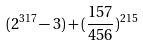<formula> <loc_0><loc_0><loc_500><loc_500>( 2 ^ { 3 1 7 } - 3 ) + ( \frac { 1 5 7 } { 4 5 6 } ) ^ { 2 1 5 }</formula> 